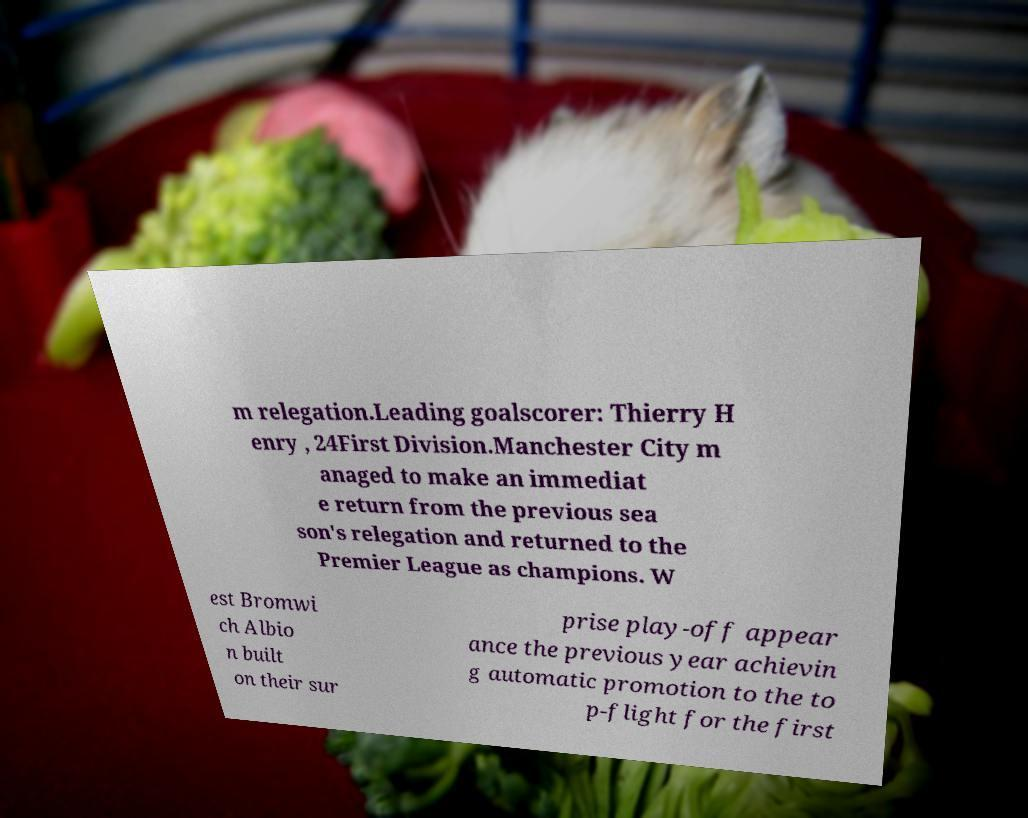Can you accurately transcribe the text from the provided image for me? m relegation.Leading goalscorer: Thierry H enry , 24First Division.Manchester City m anaged to make an immediat e return from the previous sea son's relegation and returned to the Premier League as champions. W est Bromwi ch Albio n built on their sur prise play-off appear ance the previous year achievin g automatic promotion to the to p-flight for the first 